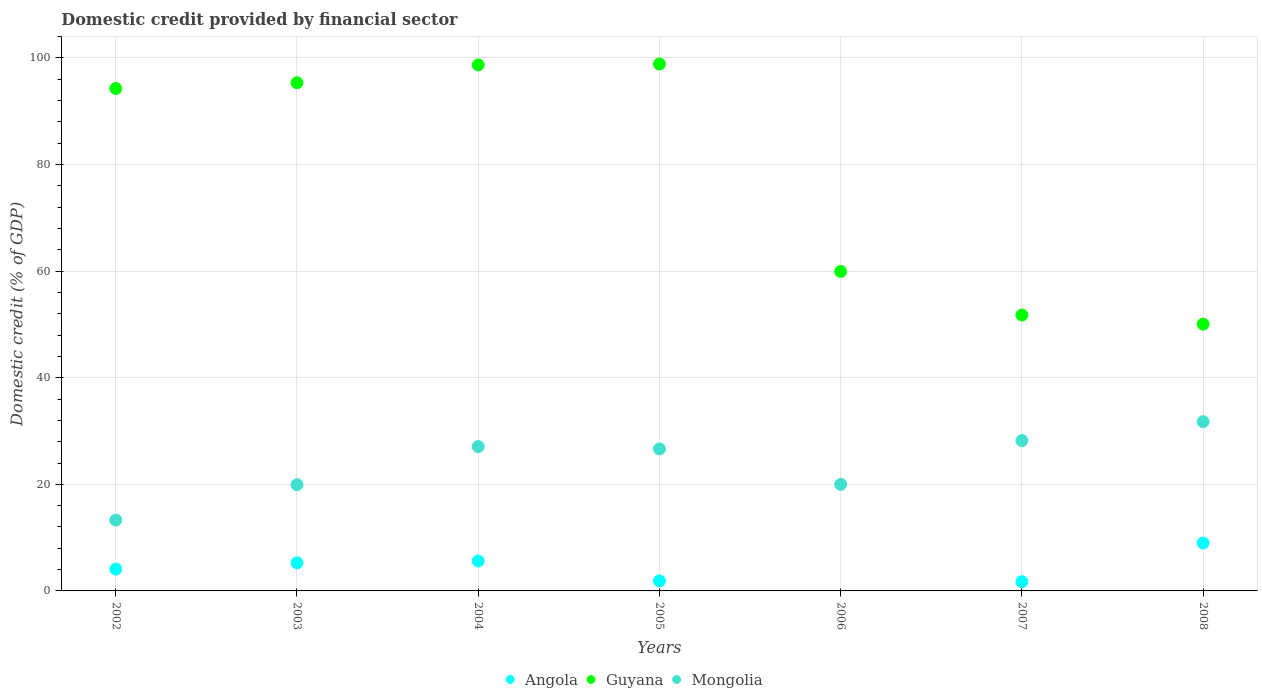How many different coloured dotlines are there?
Your response must be concise. 3. What is the domestic credit in Guyana in 2007?
Offer a terse response. 51.77. Across all years, what is the maximum domestic credit in Guyana?
Give a very brief answer. 98.87. What is the total domestic credit in Guyana in the graph?
Your answer should be very brief. 548.95. What is the difference between the domestic credit in Guyana in 2002 and that in 2005?
Provide a short and direct response. -4.6. What is the difference between the domestic credit in Angola in 2008 and the domestic credit in Mongolia in 2007?
Make the answer very short. -19.23. What is the average domestic credit in Angola per year?
Keep it short and to the point. 3.94. In the year 2007, what is the difference between the domestic credit in Mongolia and domestic credit in Guyana?
Give a very brief answer. -23.55. What is the ratio of the domestic credit in Mongolia in 2003 to that in 2004?
Your answer should be compact. 0.74. Is the difference between the domestic credit in Mongolia in 2002 and 2005 greater than the difference between the domestic credit in Guyana in 2002 and 2005?
Give a very brief answer. No. What is the difference between the highest and the second highest domestic credit in Mongolia?
Ensure brevity in your answer.  3.54. What is the difference between the highest and the lowest domestic credit in Mongolia?
Your answer should be compact. 18.47. Is the sum of the domestic credit in Guyana in 2002 and 2006 greater than the maximum domestic credit in Angola across all years?
Your answer should be very brief. Yes. Is it the case that in every year, the sum of the domestic credit in Angola and domestic credit in Guyana  is greater than the domestic credit in Mongolia?
Provide a short and direct response. Yes. Does the domestic credit in Guyana monotonically increase over the years?
Your response must be concise. No. Is the domestic credit in Angola strictly greater than the domestic credit in Mongolia over the years?
Offer a very short reply. No. How many dotlines are there?
Your response must be concise. 3. How many years are there in the graph?
Offer a terse response. 7. What is the difference between two consecutive major ticks on the Y-axis?
Provide a succinct answer. 20. Does the graph contain any zero values?
Give a very brief answer. Yes. How many legend labels are there?
Make the answer very short. 3. How are the legend labels stacked?
Provide a short and direct response. Horizontal. What is the title of the graph?
Offer a terse response. Domestic credit provided by financial sector. Does "St. Vincent and the Grenadines" appear as one of the legend labels in the graph?
Your answer should be compact. No. What is the label or title of the X-axis?
Your answer should be compact. Years. What is the label or title of the Y-axis?
Keep it short and to the point. Domestic credit (% of GDP). What is the Domestic credit (% of GDP) in Angola in 2002?
Make the answer very short. 4.09. What is the Domestic credit (% of GDP) of Guyana in 2002?
Make the answer very short. 94.27. What is the Domestic credit (% of GDP) in Mongolia in 2002?
Provide a short and direct response. 13.28. What is the Domestic credit (% of GDP) in Angola in 2003?
Offer a very short reply. 5.28. What is the Domestic credit (% of GDP) in Guyana in 2003?
Give a very brief answer. 95.35. What is the Domestic credit (% of GDP) of Mongolia in 2003?
Your answer should be very brief. 19.93. What is the Domestic credit (% of GDP) in Angola in 2004?
Provide a short and direct response. 5.62. What is the Domestic credit (% of GDP) of Guyana in 2004?
Offer a terse response. 98.69. What is the Domestic credit (% of GDP) in Mongolia in 2004?
Your answer should be very brief. 27.09. What is the Domestic credit (% of GDP) in Angola in 2005?
Your answer should be compact. 1.88. What is the Domestic credit (% of GDP) of Guyana in 2005?
Your answer should be compact. 98.87. What is the Domestic credit (% of GDP) of Mongolia in 2005?
Keep it short and to the point. 26.65. What is the Domestic credit (% of GDP) in Guyana in 2006?
Your answer should be very brief. 59.94. What is the Domestic credit (% of GDP) in Mongolia in 2006?
Your answer should be compact. 19.99. What is the Domestic credit (% of GDP) of Angola in 2007?
Your answer should be compact. 1.74. What is the Domestic credit (% of GDP) in Guyana in 2007?
Provide a succinct answer. 51.77. What is the Domestic credit (% of GDP) in Mongolia in 2007?
Your answer should be compact. 28.21. What is the Domestic credit (% of GDP) in Angola in 2008?
Give a very brief answer. 8.98. What is the Domestic credit (% of GDP) in Guyana in 2008?
Provide a succinct answer. 50.06. What is the Domestic credit (% of GDP) of Mongolia in 2008?
Your answer should be compact. 31.76. Across all years, what is the maximum Domestic credit (% of GDP) of Angola?
Offer a terse response. 8.98. Across all years, what is the maximum Domestic credit (% of GDP) in Guyana?
Offer a terse response. 98.87. Across all years, what is the maximum Domestic credit (% of GDP) of Mongolia?
Give a very brief answer. 31.76. Across all years, what is the minimum Domestic credit (% of GDP) of Angola?
Provide a short and direct response. 0. Across all years, what is the minimum Domestic credit (% of GDP) in Guyana?
Your answer should be very brief. 50.06. Across all years, what is the minimum Domestic credit (% of GDP) of Mongolia?
Offer a very short reply. 13.28. What is the total Domestic credit (% of GDP) of Angola in the graph?
Your response must be concise. 27.59. What is the total Domestic credit (% of GDP) of Guyana in the graph?
Keep it short and to the point. 548.95. What is the total Domestic credit (% of GDP) in Mongolia in the graph?
Your response must be concise. 166.9. What is the difference between the Domestic credit (% of GDP) of Angola in 2002 and that in 2003?
Give a very brief answer. -1.19. What is the difference between the Domestic credit (% of GDP) of Guyana in 2002 and that in 2003?
Your answer should be very brief. -1.08. What is the difference between the Domestic credit (% of GDP) of Mongolia in 2002 and that in 2003?
Your answer should be compact. -6.64. What is the difference between the Domestic credit (% of GDP) in Angola in 2002 and that in 2004?
Your response must be concise. -1.53. What is the difference between the Domestic credit (% of GDP) in Guyana in 2002 and that in 2004?
Offer a terse response. -4.42. What is the difference between the Domestic credit (% of GDP) in Mongolia in 2002 and that in 2004?
Ensure brevity in your answer.  -13.8. What is the difference between the Domestic credit (% of GDP) of Angola in 2002 and that in 2005?
Ensure brevity in your answer.  2.21. What is the difference between the Domestic credit (% of GDP) of Guyana in 2002 and that in 2005?
Make the answer very short. -4.6. What is the difference between the Domestic credit (% of GDP) of Mongolia in 2002 and that in 2005?
Your answer should be very brief. -13.36. What is the difference between the Domestic credit (% of GDP) of Guyana in 2002 and that in 2006?
Your response must be concise. 34.33. What is the difference between the Domestic credit (% of GDP) in Mongolia in 2002 and that in 2006?
Offer a very short reply. -6.7. What is the difference between the Domestic credit (% of GDP) of Angola in 2002 and that in 2007?
Provide a short and direct response. 2.36. What is the difference between the Domestic credit (% of GDP) in Guyana in 2002 and that in 2007?
Your answer should be compact. 42.5. What is the difference between the Domestic credit (% of GDP) of Mongolia in 2002 and that in 2007?
Provide a short and direct response. -14.93. What is the difference between the Domestic credit (% of GDP) of Angola in 2002 and that in 2008?
Your answer should be compact. -4.89. What is the difference between the Domestic credit (% of GDP) in Guyana in 2002 and that in 2008?
Offer a terse response. 44.21. What is the difference between the Domestic credit (% of GDP) in Mongolia in 2002 and that in 2008?
Give a very brief answer. -18.47. What is the difference between the Domestic credit (% of GDP) in Angola in 2003 and that in 2004?
Your answer should be compact. -0.34. What is the difference between the Domestic credit (% of GDP) in Guyana in 2003 and that in 2004?
Ensure brevity in your answer.  -3.34. What is the difference between the Domestic credit (% of GDP) in Mongolia in 2003 and that in 2004?
Offer a terse response. -7.16. What is the difference between the Domestic credit (% of GDP) of Angola in 2003 and that in 2005?
Give a very brief answer. 3.4. What is the difference between the Domestic credit (% of GDP) of Guyana in 2003 and that in 2005?
Your answer should be very brief. -3.52. What is the difference between the Domestic credit (% of GDP) in Mongolia in 2003 and that in 2005?
Ensure brevity in your answer.  -6.72. What is the difference between the Domestic credit (% of GDP) of Guyana in 2003 and that in 2006?
Provide a succinct answer. 35.41. What is the difference between the Domestic credit (% of GDP) in Mongolia in 2003 and that in 2006?
Keep it short and to the point. -0.06. What is the difference between the Domestic credit (% of GDP) in Angola in 2003 and that in 2007?
Give a very brief answer. 3.54. What is the difference between the Domestic credit (% of GDP) in Guyana in 2003 and that in 2007?
Offer a terse response. 43.59. What is the difference between the Domestic credit (% of GDP) of Mongolia in 2003 and that in 2007?
Make the answer very short. -8.29. What is the difference between the Domestic credit (% of GDP) of Angola in 2003 and that in 2008?
Provide a short and direct response. -3.71. What is the difference between the Domestic credit (% of GDP) in Guyana in 2003 and that in 2008?
Make the answer very short. 45.3. What is the difference between the Domestic credit (% of GDP) of Mongolia in 2003 and that in 2008?
Give a very brief answer. -11.83. What is the difference between the Domestic credit (% of GDP) in Angola in 2004 and that in 2005?
Your answer should be very brief. 3.74. What is the difference between the Domestic credit (% of GDP) of Guyana in 2004 and that in 2005?
Give a very brief answer. -0.18. What is the difference between the Domestic credit (% of GDP) in Mongolia in 2004 and that in 2005?
Keep it short and to the point. 0.44. What is the difference between the Domestic credit (% of GDP) of Guyana in 2004 and that in 2006?
Provide a succinct answer. 38.75. What is the difference between the Domestic credit (% of GDP) in Mongolia in 2004 and that in 2006?
Ensure brevity in your answer.  7.1. What is the difference between the Domestic credit (% of GDP) in Angola in 2004 and that in 2007?
Keep it short and to the point. 3.88. What is the difference between the Domestic credit (% of GDP) of Guyana in 2004 and that in 2007?
Offer a very short reply. 46.93. What is the difference between the Domestic credit (% of GDP) in Mongolia in 2004 and that in 2007?
Provide a succinct answer. -1.13. What is the difference between the Domestic credit (% of GDP) in Angola in 2004 and that in 2008?
Keep it short and to the point. -3.37. What is the difference between the Domestic credit (% of GDP) in Guyana in 2004 and that in 2008?
Give a very brief answer. 48.64. What is the difference between the Domestic credit (% of GDP) of Mongolia in 2004 and that in 2008?
Your answer should be very brief. -4.67. What is the difference between the Domestic credit (% of GDP) of Guyana in 2005 and that in 2006?
Offer a very short reply. 38.93. What is the difference between the Domestic credit (% of GDP) of Mongolia in 2005 and that in 2006?
Keep it short and to the point. 6.66. What is the difference between the Domestic credit (% of GDP) in Angola in 2005 and that in 2007?
Your response must be concise. 0.14. What is the difference between the Domestic credit (% of GDP) in Guyana in 2005 and that in 2007?
Provide a succinct answer. 47.1. What is the difference between the Domestic credit (% of GDP) of Mongolia in 2005 and that in 2007?
Provide a short and direct response. -1.57. What is the difference between the Domestic credit (% of GDP) of Angola in 2005 and that in 2008?
Make the answer very short. -7.11. What is the difference between the Domestic credit (% of GDP) in Guyana in 2005 and that in 2008?
Make the answer very short. 48.81. What is the difference between the Domestic credit (% of GDP) of Mongolia in 2005 and that in 2008?
Offer a very short reply. -5.11. What is the difference between the Domestic credit (% of GDP) in Guyana in 2006 and that in 2007?
Give a very brief answer. 8.17. What is the difference between the Domestic credit (% of GDP) of Mongolia in 2006 and that in 2007?
Ensure brevity in your answer.  -8.23. What is the difference between the Domestic credit (% of GDP) in Guyana in 2006 and that in 2008?
Provide a succinct answer. 9.88. What is the difference between the Domestic credit (% of GDP) of Mongolia in 2006 and that in 2008?
Offer a terse response. -11.77. What is the difference between the Domestic credit (% of GDP) of Angola in 2007 and that in 2008?
Give a very brief answer. -7.25. What is the difference between the Domestic credit (% of GDP) of Guyana in 2007 and that in 2008?
Provide a succinct answer. 1.71. What is the difference between the Domestic credit (% of GDP) of Mongolia in 2007 and that in 2008?
Make the answer very short. -3.54. What is the difference between the Domestic credit (% of GDP) in Angola in 2002 and the Domestic credit (% of GDP) in Guyana in 2003?
Offer a terse response. -91.26. What is the difference between the Domestic credit (% of GDP) of Angola in 2002 and the Domestic credit (% of GDP) of Mongolia in 2003?
Keep it short and to the point. -15.84. What is the difference between the Domestic credit (% of GDP) of Guyana in 2002 and the Domestic credit (% of GDP) of Mongolia in 2003?
Your response must be concise. 74.34. What is the difference between the Domestic credit (% of GDP) in Angola in 2002 and the Domestic credit (% of GDP) in Guyana in 2004?
Give a very brief answer. -94.6. What is the difference between the Domestic credit (% of GDP) of Angola in 2002 and the Domestic credit (% of GDP) of Mongolia in 2004?
Provide a short and direct response. -23. What is the difference between the Domestic credit (% of GDP) in Guyana in 2002 and the Domestic credit (% of GDP) in Mongolia in 2004?
Provide a succinct answer. 67.18. What is the difference between the Domestic credit (% of GDP) in Angola in 2002 and the Domestic credit (% of GDP) in Guyana in 2005?
Provide a succinct answer. -94.78. What is the difference between the Domestic credit (% of GDP) in Angola in 2002 and the Domestic credit (% of GDP) in Mongolia in 2005?
Your answer should be compact. -22.55. What is the difference between the Domestic credit (% of GDP) of Guyana in 2002 and the Domestic credit (% of GDP) of Mongolia in 2005?
Make the answer very short. 67.62. What is the difference between the Domestic credit (% of GDP) in Angola in 2002 and the Domestic credit (% of GDP) in Guyana in 2006?
Make the answer very short. -55.85. What is the difference between the Domestic credit (% of GDP) in Angola in 2002 and the Domestic credit (% of GDP) in Mongolia in 2006?
Provide a succinct answer. -15.9. What is the difference between the Domestic credit (% of GDP) in Guyana in 2002 and the Domestic credit (% of GDP) in Mongolia in 2006?
Offer a very short reply. 74.28. What is the difference between the Domestic credit (% of GDP) in Angola in 2002 and the Domestic credit (% of GDP) in Guyana in 2007?
Your answer should be very brief. -47.68. What is the difference between the Domestic credit (% of GDP) of Angola in 2002 and the Domestic credit (% of GDP) of Mongolia in 2007?
Offer a very short reply. -24.12. What is the difference between the Domestic credit (% of GDP) in Guyana in 2002 and the Domestic credit (% of GDP) in Mongolia in 2007?
Offer a terse response. 66.06. What is the difference between the Domestic credit (% of GDP) in Angola in 2002 and the Domestic credit (% of GDP) in Guyana in 2008?
Your answer should be compact. -45.96. What is the difference between the Domestic credit (% of GDP) in Angola in 2002 and the Domestic credit (% of GDP) in Mongolia in 2008?
Provide a short and direct response. -27.66. What is the difference between the Domestic credit (% of GDP) in Guyana in 2002 and the Domestic credit (% of GDP) in Mongolia in 2008?
Give a very brief answer. 62.52. What is the difference between the Domestic credit (% of GDP) of Angola in 2003 and the Domestic credit (% of GDP) of Guyana in 2004?
Ensure brevity in your answer.  -93.41. What is the difference between the Domestic credit (% of GDP) of Angola in 2003 and the Domestic credit (% of GDP) of Mongolia in 2004?
Your answer should be very brief. -21.81. What is the difference between the Domestic credit (% of GDP) of Guyana in 2003 and the Domestic credit (% of GDP) of Mongolia in 2004?
Ensure brevity in your answer.  68.27. What is the difference between the Domestic credit (% of GDP) in Angola in 2003 and the Domestic credit (% of GDP) in Guyana in 2005?
Your answer should be very brief. -93.59. What is the difference between the Domestic credit (% of GDP) of Angola in 2003 and the Domestic credit (% of GDP) of Mongolia in 2005?
Provide a short and direct response. -21.37. What is the difference between the Domestic credit (% of GDP) in Guyana in 2003 and the Domestic credit (% of GDP) in Mongolia in 2005?
Keep it short and to the point. 68.71. What is the difference between the Domestic credit (% of GDP) in Angola in 2003 and the Domestic credit (% of GDP) in Guyana in 2006?
Offer a very short reply. -54.66. What is the difference between the Domestic credit (% of GDP) in Angola in 2003 and the Domestic credit (% of GDP) in Mongolia in 2006?
Provide a succinct answer. -14.71. What is the difference between the Domestic credit (% of GDP) of Guyana in 2003 and the Domestic credit (% of GDP) of Mongolia in 2006?
Give a very brief answer. 75.37. What is the difference between the Domestic credit (% of GDP) in Angola in 2003 and the Domestic credit (% of GDP) in Guyana in 2007?
Keep it short and to the point. -46.49. What is the difference between the Domestic credit (% of GDP) in Angola in 2003 and the Domestic credit (% of GDP) in Mongolia in 2007?
Make the answer very short. -22.94. What is the difference between the Domestic credit (% of GDP) of Guyana in 2003 and the Domestic credit (% of GDP) of Mongolia in 2007?
Make the answer very short. 67.14. What is the difference between the Domestic credit (% of GDP) in Angola in 2003 and the Domestic credit (% of GDP) in Guyana in 2008?
Your answer should be compact. -44.78. What is the difference between the Domestic credit (% of GDP) of Angola in 2003 and the Domestic credit (% of GDP) of Mongolia in 2008?
Offer a very short reply. -26.48. What is the difference between the Domestic credit (% of GDP) of Guyana in 2003 and the Domestic credit (% of GDP) of Mongolia in 2008?
Make the answer very short. 63.6. What is the difference between the Domestic credit (% of GDP) of Angola in 2004 and the Domestic credit (% of GDP) of Guyana in 2005?
Provide a succinct answer. -93.25. What is the difference between the Domestic credit (% of GDP) in Angola in 2004 and the Domestic credit (% of GDP) in Mongolia in 2005?
Your answer should be very brief. -21.03. What is the difference between the Domestic credit (% of GDP) in Guyana in 2004 and the Domestic credit (% of GDP) in Mongolia in 2005?
Your response must be concise. 72.05. What is the difference between the Domestic credit (% of GDP) of Angola in 2004 and the Domestic credit (% of GDP) of Guyana in 2006?
Offer a terse response. -54.32. What is the difference between the Domestic credit (% of GDP) in Angola in 2004 and the Domestic credit (% of GDP) in Mongolia in 2006?
Ensure brevity in your answer.  -14.37. What is the difference between the Domestic credit (% of GDP) of Guyana in 2004 and the Domestic credit (% of GDP) of Mongolia in 2006?
Ensure brevity in your answer.  78.7. What is the difference between the Domestic credit (% of GDP) of Angola in 2004 and the Domestic credit (% of GDP) of Guyana in 2007?
Make the answer very short. -46.15. What is the difference between the Domestic credit (% of GDP) in Angola in 2004 and the Domestic credit (% of GDP) in Mongolia in 2007?
Give a very brief answer. -22.6. What is the difference between the Domestic credit (% of GDP) in Guyana in 2004 and the Domestic credit (% of GDP) in Mongolia in 2007?
Your response must be concise. 70.48. What is the difference between the Domestic credit (% of GDP) in Angola in 2004 and the Domestic credit (% of GDP) in Guyana in 2008?
Your answer should be very brief. -44.44. What is the difference between the Domestic credit (% of GDP) in Angola in 2004 and the Domestic credit (% of GDP) in Mongolia in 2008?
Give a very brief answer. -26.14. What is the difference between the Domestic credit (% of GDP) of Guyana in 2004 and the Domestic credit (% of GDP) of Mongolia in 2008?
Your response must be concise. 66.94. What is the difference between the Domestic credit (% of GDP) in Angola in 2005 and the Domestic credit (% of GDP) in Guyana in 2006?
Keep it short and to the point. -58.06. What is the difference between the Domestic credit (% of GDP) in Angola in 2005 and the Domestic credit (% of GDP) in Mongolia in 2006?
Offer a terse response. -18.11. What is the difference between the Domestic credit (% of GDP) in Guyana in 2005 and the Domestic credit (% of GDP) in Mongolia in 2006?
Ensure brevity in your answer.  78.88. What is the difference between the Domestic credit (% of GDP) of Angola in 2005 and the Domestic credit (% of GDP) of Guyana in 2007?
Give a very brief answer. -49.89. What is the difference between the Domestic credit (% of GDP) in Angola in 2005 and the Domestic credit (% of GDP) in Mongolia in 2007?
Offer a terse response. -26.34. What is the difference between the Domestic credit (% of GDP) of Guyana in 2005 and the Domestic credit (% of GDP) of Mongolia in 2007?
Your response must be concise. 70.66. What is the difference between the Domestic credit (% of GDP) in Angola in 2005 and the Domestic credit (% of GDP) in Guyana in 2008?
Offer a very short reply. -48.18. What is the difference between the Domestic credit (% of GDP) in Angola in 2005 and the Domestic credit (% of GDP) in Mongolia in 2008?
Your answer should be compact. -29.88. What is the difference between the Domestic credit (% of GDP) in Guyana in 2005 and the Domestic credit (% of GDP) in Mongolia in 2008?
Make the answer very short. 67.12. What is the difference between the Domestic credit (% of GDP) of Guyana in 2006 and the Domestic credit (% of GDP) of Mongolia in 2007?
Make the answer very short. 31.73. What is the difference between the Domestic credit (% of GDP) of Guyana in 2006 and the Domestic credit (% of GDP) of Mongolia in 2008?
Your answer should be very brief. 28.19. What is the difference between the Domestic credit (% of GDP) in Angola in 2007 and the Domestic credit (% of GDP) in Guyana in 2008?
Your response must be concise. -48.32. What is the difference between the Domestic credit (% of GDP) of Angola in 2007 and the Domestic credit (% of GDP) of Mongolia in 2008?
Your response must be concise. -30.02. What is the difference between the Domestic credit (% of GDP) in Guyana in 2007 and the Domestic credit (% of GDP) in Mongolia in 2008?
Ensure brevity in your answer.  20.01. What is the average Domestic credit (% of GDP) of Angola per year?
Your answer should be very brief. 3.94. What is the average Domestic credit (% of GDP) in Guyana per year?
Offer a terse response. 78.42. What is the average Domestic credit (% of GDP) in Mongolia per year?
Provide a short and direct response. 23.84. In the year 2002, what is the difference between the Domestic credit (% of GDP) of Angola and Domestic credit (% of GDP) of Guyana?
Make the answer very short. -90.18. In the year 2002, what is the difference between the Domestic credit (% of GDP) in Angola and Domestic credit (% of GDP) in Mongolia?
Your response must be concise. -9.19. In the year 2002, what is the difference between the Domestic credit (% of GDP) in Guyana and Domestic credit (% of GDP) in Mongolia?
Make the answer very short. 80.99. In the year 2003, what is the difference between the Domestic credit (% of GDP) of Angola and Domestic credit (% of GDP) of Guyana?
Provide a succinct answer. -90.08. In the year 2003, what is the difference between the Domestic credit (% of GDP) in Angola and Domestic credit (% of GDP) in Mongolia?
Ensure brevity in your answer.  -14.65. In the year 2003, what is the difference between the Domestic credit (% of GDP) in Guyana and Domestic credit (% of GDP) in Mongolia?
Your answer should be very brief. 75.43. In the year 2004, what is the difference between the Domestic credit (% of GDP) of Angola and Domestic credit (% of GDP) of Guyana?
Your response must be concise. -93.08. In the year 2004, what is the difference between the Domestic credit (% of GDP) in Angola and Domestic credit (% of GDP) in Mongolia?
Keep it short and to the point. -21.47. In the year 2004, what is the difference between the Domestic credit (% of GDP) of Guyana and Domestic credit (% of GDP) of Mongolia?
Your response must be concise. 71.61. In the year 2005, what is the difference between the Domestic credit (% of GDP) of Angola and Domestic credit (% of GDP) of Guyana?
Offer a very short reply. -96.99. In the year 2005, what is the difference between the Domestic credit (% of GDP) of Angola and Domestic credit (% of GDP) of Mongolia?
Provide a short and direct response. -24.77. In the year 2005, what is the difference between the Domestic credit (% of GDP) of Guyana and Domestic credit (% of GDP) of Mongolia?
Keep it short and to the point. 72.23. In the year 2006, what is the difference between the Domestic credit (% of GDP) of Guyana and Domestic credit (% of GDP) of Mongolia?
Provide a short and direct response. 39.95. In the year 2007, what is the difference between the Domestic credit (% of GDP) in Angola and Domestic credit (% of GDP) in Guyana?
Offer a terse response. -50.03. In the year 2007, what is the difference between the Domestic credit (% of GDP) of Angola and Domestic credit (% of GDP) of Mongolia?
Make the answer very short. -26.48. In the year 2007, what is the difference between the Domestic credit (% of GDP) in Guyana and Domestic credit (% of GDP) in Mongolia?
Ensure brevity in your answer.  23.55. In the year 2008, what is the difference between the Domestic credit (% of GDP) of Angola and Domestic credit (% of GDP) of Guyana?
Offer a very short reply. -41.07. In the year 2008, what is the difference between the Domestic credit (% of GDP) of Angola and Domestic credit (% of GDP) of Mongolia?
Provide a short and direct response. -22.77. In the year 2008, what is the difference between the Domestic credit (% of GDP) in Guyana and Domestic credit (% of GDP) in Mongolia?
Offer a terse response. 18.3. What is the ratio of the Domestic credit (% of GDP) of Angola in 2002 to that in 2003?
Keep it short and to the point. 0.78. What is the ratio of the Domestic credit (% of GDP) of Guyana in 2002 to that in 2003?
Make the answer very short. 0.99. What is the ratio of the Domestic credit (% of GDP) in Mongolia in 2002 to that in 2003?
Your answer should be compact. 0.67. What is the ratio of the Domestic credit (% of GDP) in Angola in 2002 to that in 2004?
Your answer should be compact. 0.73. What is the ratio of the Domestic credit (% of GDP) of Guyana in 2002 to that in 2004?
Offer a very short reply. 0.96. What is the ratio of the Domestic credit (% of GDP) of Mongolia in 2002 to that in 2004?
Your answer should be compact. 0.49. What is the ratio of the Domestic credit (% of GDP) of Angola in 2002 to that in 2005?
Make the answer very short. 2.18. What is the ratio of the Domestic credit (% of GDP) of Guyana in 2002 to that in 2005?
Ensure brevity in your answer.  0.95. What is the ratio of the Domestic credit (% of GDP) of Mongolia in 2002 to that in 2005?
Make the answer very short. 0.5. What is the ratio of the Domestic credit (% of GDP) in Guyana in 2002 to that in 2006?
Provide a short and direct response. 1.57. What is the ratio of the Domestic credit (% of GDP) in Mongolia in 2002 to that in 2006?
Ensure brevity in your answer.  0.66. What is the ratio of the Domestic credit (% of GDP) of Angola in 2002 to that in 2007?
Keep it short and to the point. 2.36. What is the ratio of the Domestic credit (% of GDP) of Guyana in 2002 to that in 2007?
Ensure brevity in your answer.  1.82. What is the ratio of the Domestic credit (% of GDP) of Mongolia in 2002 to that in 2007?
Keep it short and to the point. 0.47. What is the ratio of the Domestic credit (% of GDP) in Angola in 2002 to that in 2008?
Make the answer very short. 0.46. What is the ratio of the Domestic credit (% of GDP) of Guyana in 2002 to that in 2008?
Offer a very short reply. 1.88. What is the ratio of the Domestic credit (% of GDP) in Mongolia in 2002 to that in 2008?
Your response must be concise. 0.42. What is the ratio of the Domestic credit (% of GDP) of Angola in 2003 to that in 2004?
Offer a terse response. 0.94. What is the ratio of the Domestic credit (% of GDP) in Guyana in 2003 to that in 2004?
Make the answer very short. 0.97. What is the ratio of the Domestic credit (% of GDP) in Mongolia in 2003 to that in 2004?
Offer a terse response. 0.74. What is the ratio of the Domestic credit (% of GDP) of Angola in 2003 to that in 2005?
Provide a short and direct response. 2.81. What is the ratio of the Domestic credit (% of GDP) of Guyana in 2003 to that in 2005?
Ensure brevity in your answer.  0.96. What is the ratio of the Domestic credit (% of GDP) of Mongolia in 2003 to that in 2005?
Provide a short and direct response. 0.75. What is the ratio of the Domestic credit (% of GDP) of Guyana in 2003 to that in 2006?
Provide a succinct answer. 1.59. What is the ratio of the Domestic credit (% of GDP) of Angola in 2003 to that in 2007?
Make the answer very short. 3.04. What is the ratio of the Domestic credit (% of GDP) in Guyana in 2003 to that in 2007?
Make the answer very short. 1.84. What is the ratio of the Domestic credit (% of GDP) of Mongolia in 2003 to that in 2007?
Offer a terse response. 0.71. What is the ratio of the Domestic credit (% of GDP) of Angola in 2003 to that in 2008?
Provide a short and direct response. 0.59. What is the ratio of the Domestic credit (% of GDP) of Guyana in 2003 to that in 2008?
Provide a succinct answer. 1.9. What is the ratio of the Domestic credit (% of GDP) in Mongolia in 2003 to that in 2008?
Your response must be concise. 0.63. What is the ratio of the Domestic credit (% of GDP) of Angola in 2004 to that in 2005?
Offer a terse response. 2.99. What is the ratio of the Domestic credit (% of GDP) of Guyana in 2004 to that in 2005?
Offer a terse response. 1. What is the ratio of the Domestic credit (% of GDP) in Mongolia in 2004 to that in 2005?
Your answer should be very brief. 1.02. What is the ratio of the Domestic credit (% of GDP) in Guyana in 2004 to that in 2006?
Your answer should be very brief. 1.65. What is the ratio of the Domestic credit (% of GDP) in Mongolia in 2004 to that in 2006?
Provide a short and direct response. 1.36. What is the ratio of the Domestic credit (% of GDP) of Angola in 2004 to that in 2007?
Your response must be concise. 3.24. What is the ratio of the Domestic credit (% of GDP) in Guyana in 2004 to that in 2007?
Make the answer very short. 1.91. What is the ratio of the Domestic credit (% of GDP) of Mongolia in 2004 to that in 2007?
Offer a very short reply. 0.96. What is the ratio of the Domestic credit (% of GDP) in Angola in 2004 to that in 2008?
Offer a terse response. 0.63. What is the ratio of the Domestic credit (% of GDP) of Guyana in 2004 to that in 2008?
Make the answer very short. 1.97. What is the ratio of the Domestic credit (% of GDP) in Mongolia in 2004 to that in 2008?
Provide a succinct answer. 0.85. What is the ratio of the Domestic credit (% of GDP) in Guyana in 2005 to that in 2006?
Provide a succinct answer. 1.65. What is the ratio of the Domestic credit (% of GDP) in Mongolia in 2005 to that in 2006?
Provide a short and direct response. 1.33. What is the ratio of the Domestic credit (% of GDP) in Angola in 2005 to that in 2007?
Offer a very short reply. 1.08. What is the ratio of the Domestic credit (% of GDP) of Guyana in 2005 to that in 2007?
Ensure brevity in your answer.  1.91. What is the ratio of the Domestic credit (% of GDP) in Angola in 2005 to that in 2008?
Offer a very short reply. 0.21. What is the ratio of the Domestic credit (% of GDP) of Guyana in 2005 to that in 2008?
Offer a terse response. 1.98. What is the ratio of the Domestic credit (% of GDP) of Mongolia in 2005 to that in 2008?
Give a very brief answer. 0.84. What is the ratio of the Domestic credit (% of GDP) of Guyana in 2006 to that in 2007?
Ensure brevity in your answer.  1.16. What is the ratio of the Domestic credit (% of GDP) in Mongolia in 2006 to that in 2007?
Your answer should be very brief. 0.71. What is the ratio of the Domestic credit (% of GDP) of Guyana in 2006 to that in 2008?
Provide a succinct answer. 1.2. What is the ratio of the Domestic credit (% of GDP) of Mongolia in 2006 to that in 2008?
Your answer should be very brief. 0.63. What is the ratio of the Domestic credit (% of GDP) in Angola in 2007 to that in 2008?
Make the answer very short. 0.19. What is the ratio of the Domestic credit (% of GDP) of Guyana in 2007 to that in 2008?
Provide a short and direct response. 1.03. What is the ratio of the Domestic credit (% of GDP) of Mongolia in 2007 to that in 2008?
Ensure brevity in your answer.  0.89. What is the difference between the highest and the second highest Domestic credit (% of GDP) in Angola?
Your answer should be compact. 3.37. What is the difference between the highest and the second highest Domestic credit (% of GDP) in Guyana?
Your response must be concise. 0.18. What is the difference between the highest and the second highest Domestic credit (% of GDP) in Mongolia?
Offer a very short reply. 3.54. What is the difference between the highest and the lowest Domestic credit (% of GDP) of Angola?
Offer a very short reply. 8.98. What is the difference between the highest and the lowest Domestic credit (% of GDP) in Guyana?
Give a very brief answer. 48.81. What is the difference between the highest and the lowest Domestic credit (% of GDP) of Mongolia?
Ensure brevity in your answer.  18.47. 